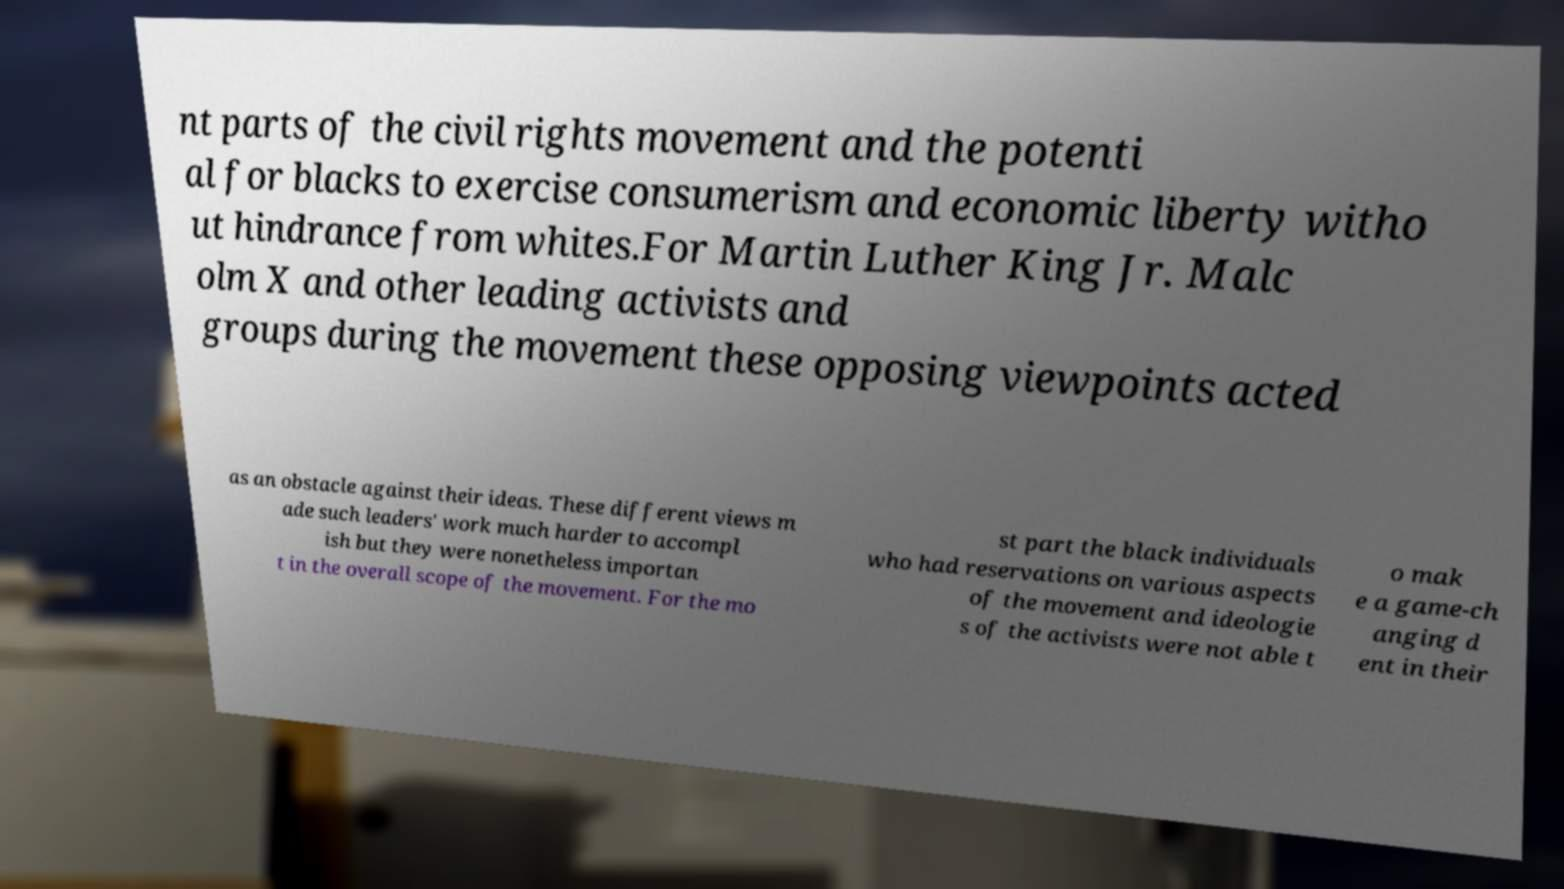Can you accurately transcribe the text from the provided image for me? nt parts of the civil rights movement and the potenti al for blacks to exercise consumerism and economic liberty witho ut hindrance from whites.For Martin Luther King Jr. Malc olm X and other leading activists and groups during the movement these opposing viewpoints acted as an obstacle against their ideas. These different views m ade such leaders' work much harder to accompl ish but they were nonetheless importan t in the overall scope of the movement. For the mo st part the black individuals who had reservations on various aspects of the movement and ideologie s of the activists were not able t o mak e a game-ch anging d ent in their 